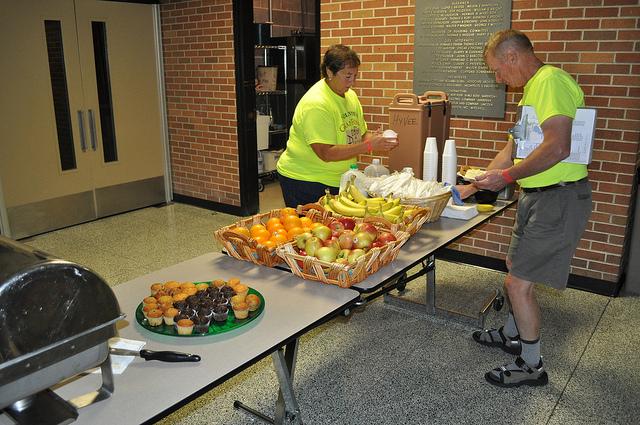What color are the man's socks?
Give a very brief answer. Gray. Are they getting ready for a morning event?
Keep it brief. Yes. How many women are in this picture?
Be succinct. 1. 